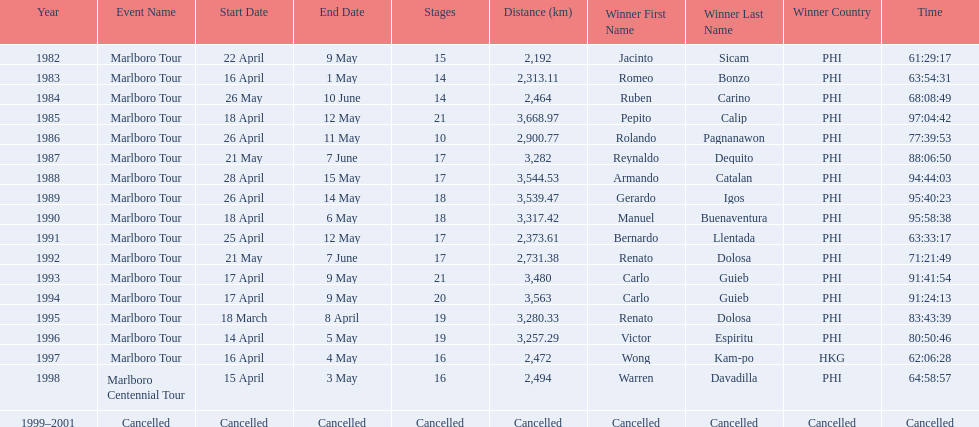Who was the only winner to have their time below 61:45:00? Jacinto Sicam. 